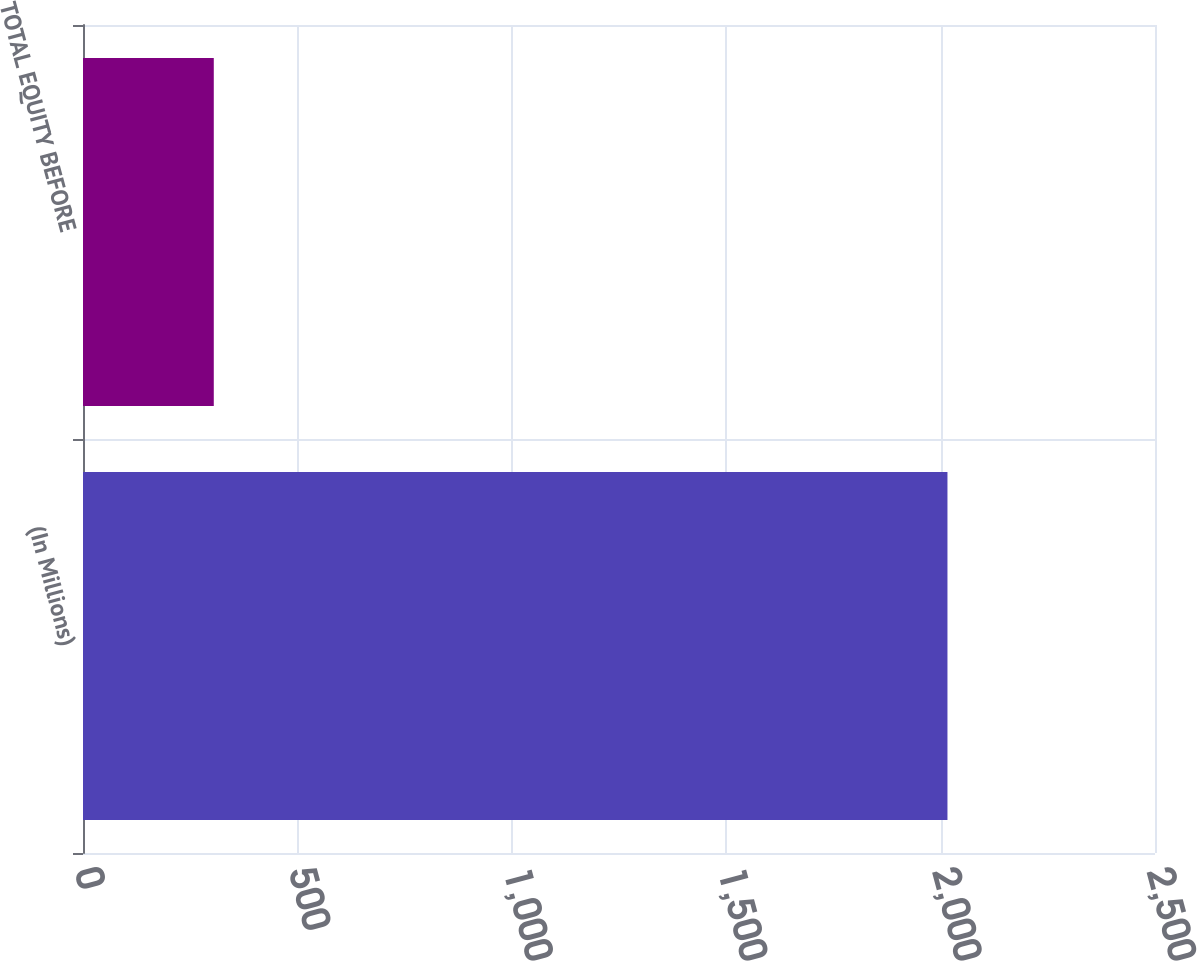Convert chart to OTSL. <chart><loc_0><loc_0><loc_500><loc_500><bar_chart><fcel>(In Millions)<fcel>TOTAL EQUITY BEFORE<nl><fcel>2016<fcel>305<nl></chart> 